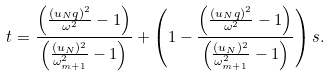<formula> <loc_0><loc_0><loc_500><loc_500>t = \frac { \left ( \frac { ( u _ { N } q ) ^ { 2 } } { \omega ^ { 2 } } - 1 \right ) } { \left ( \frac { ( u _ { N } ) ^ { 2 } } { \omega _ { m + 1 } ^ { 2 } } - 1 \right ) } + \left ( 1 - \frac { \left ( \frac { ( u _ { N } q ) ^ { 2 } } { \omega ^ { 2 } } - 1 \right ) } { \left ( \frac { ( u _ { N } ) ^ { 2 } } { \omega _ { m + 1 } ^ { 2 } } - 1 \right ) } \right ) s .</formula> 